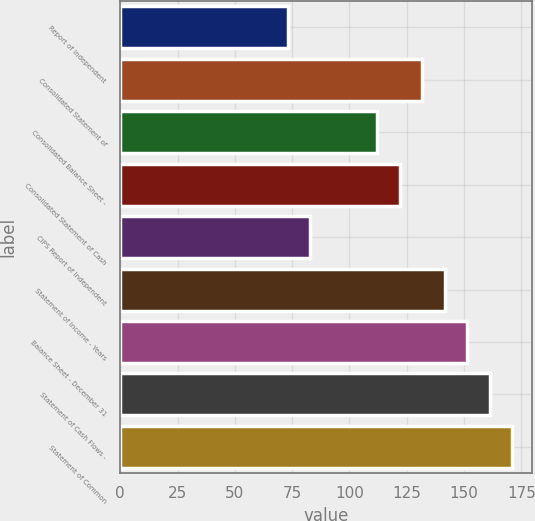Convert chart. <chart><loc_0><loc_0><loc_500><loc_500><bar_chart><fcel>Report of Independent<fcel>Consolidated Statement of<fcel>Consolidated Balance Sheet -<fcel>Consolidated Statement of Cash<fcel>CIPS Report of Independent<fcel>Statement of Income - Years<fcel>Balance Sheet - December 31<fcel>Statement of Cash Flows -<fcel>Statement of Common<nl><fcel>73<fcel>131.8<fcel>112.2<fcel>122<fcel>82.8<fcel>141.6<fcel>151.4<fcel>161.2<fcel>171<nl></chart> 